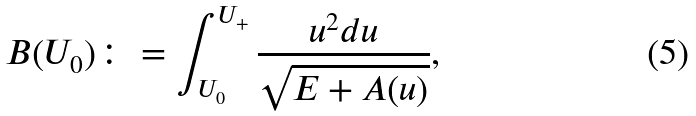<formula> <loc_0><loc_0><loc_500><loc_500>B ( U _ { 0 } ) \colon = \int _ { U _ { 0 } } ^ { U _ { + } } \frac { u ^ { 2 } d u } { \sqrt { E + A ( u ) } } ,</formula> 